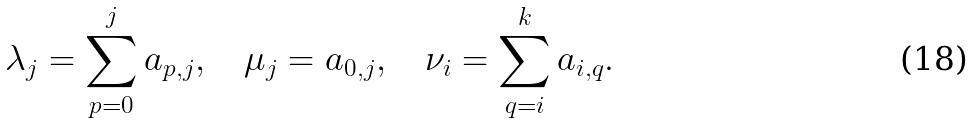<formula> <loc_0><loc_0><loc_500><loc_500>\lambda _ { j } = \sum _ { p = 0 } ^ { j } a _ { p , j } , \quad \mu _ { j } = a _ { 0 , j } , \quad \nu _ { i } = \sum _ { q = i } ^ { k } a _ { i , q } .</formula> 